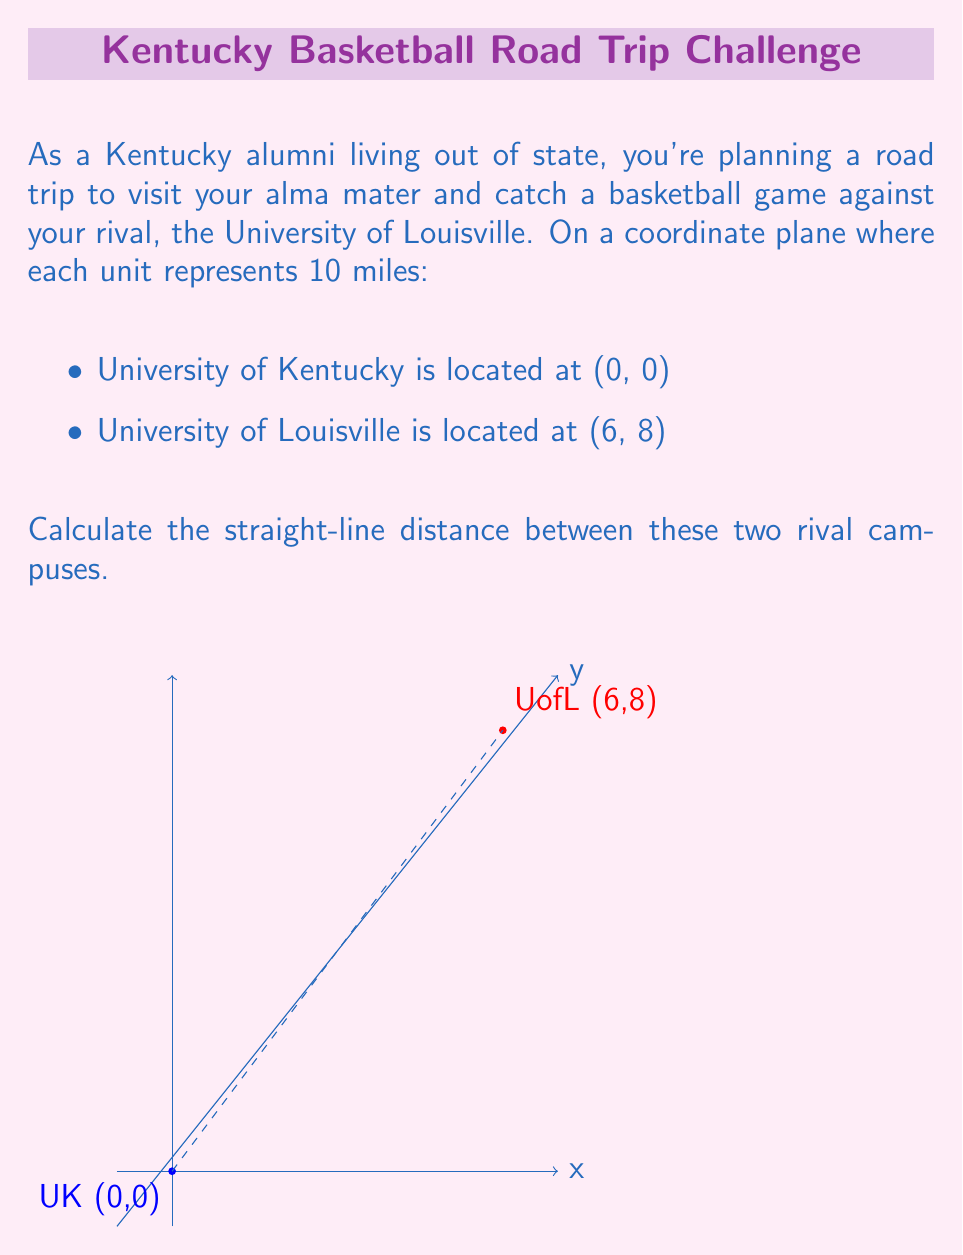Help me with this question. To find the straight-line distance between two points on a coordinate plane, we can use the distance formula, which is derived from the Pythagorean theorem:

$$d = \sqrt{(x_2 - x_1)^2 + (y_2 - y_1)^2}$$

Where $(x_1, y_1)$ is the first point and $(x_2, y_2)$ is the second point.

In this case:
- University of Kentucky: $(x_1, y_1) = (0, 0)$
- University of Louisville: $(x_2, y_2) = (6, 8)$

Let's plug these values into the formula:

$$\begin{align}
d &= \sqrt{(6 - 0)^2 + (8 - 0)^2} \\
&= \sqrt{6^2 + 8^2} \\
&= \sqrt{36 + 64} \\
&= \sqrt{100} \\
&= 10
\end{align}$$

The result is 10 units on our coordinate plane. Since each unit represents 10 miles:

$10 \times 10 \text{ miles} = 100 \text{ miles}$

Therefore, the straight-line distance between the University of Kentucky and the University of Louisville is 100 miles.
Answer: 100 miles 